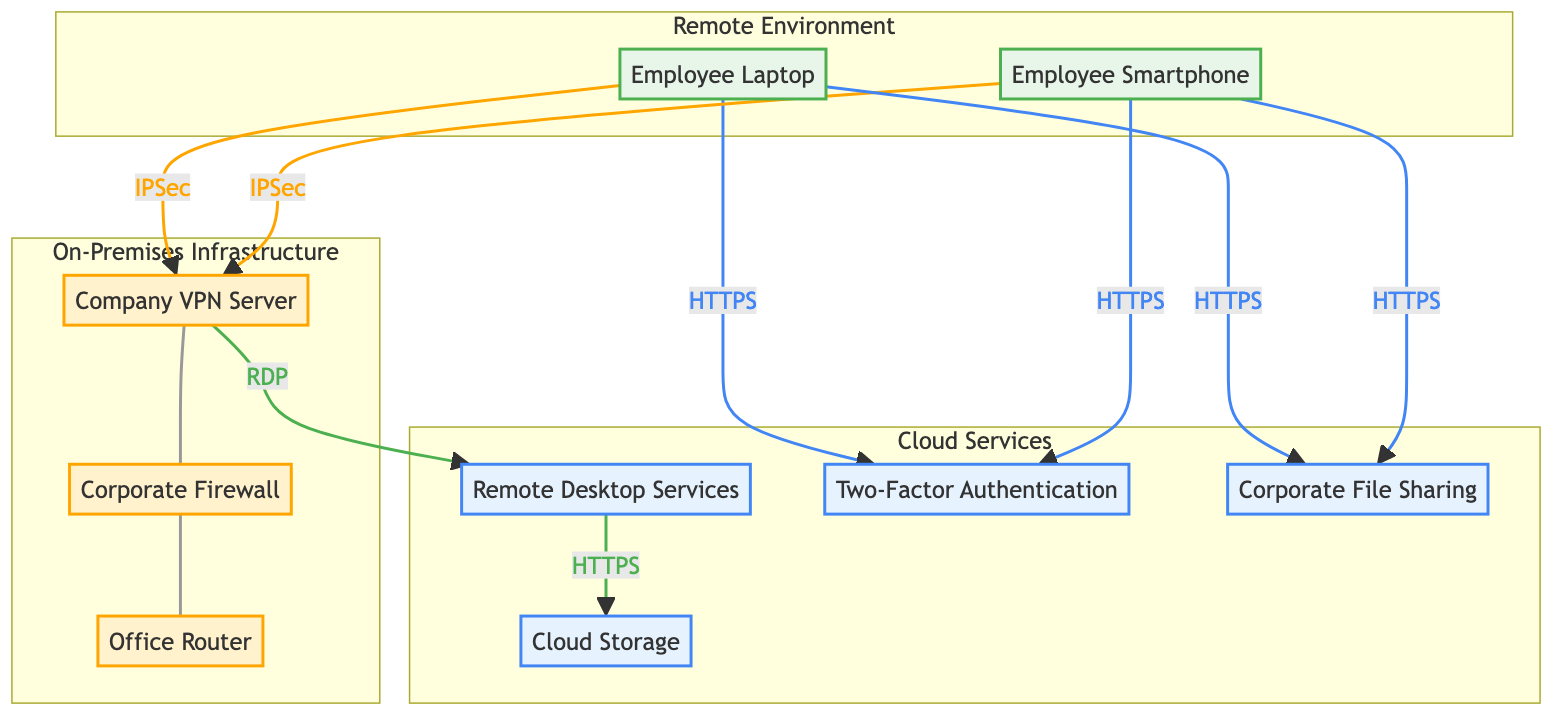What is the type of the "Company VPN Server"? The diagram indicates that the "Company VPN Server" is categorized as a "VPN Gateway".
Answer: VPN Gateway How many user endpoints are shown in the diagram? The diagram lists two user endpoints: an "Employee Laptop" and an "Employee Smartphone". Hence, the total count is 2.
Answer: 2 Which cloud service is used for cloud storage? According to the diagram, "Cloud Storage" is located in "AWS S3", indicating it is the cloud service implemented for storage purposes.
Answer: AWS S3 What protocol is used for the connection between "User Endpoints" and "Company VPN Server"? The diagram specifies that the connection is established via "IPSec" from "User Endpoints" to "Company VPN Server".
Answer: IPSec What kind of authentication is utilized in the system? The diagram mentions "Password" and "Two-Factor Authentication" as the authentication methods used, thus both are included.
Answer: Password, Two-Factor Authentication How does the "Remote Desktop Services" access "Cloud Storage"? The diagram clearly shows that "Remote Desktop Services" accesses "Cloud Storage" using the "HTTPS" protocol.
Answer: HTTPS What links the "Corporate Firewall" to the "Office Router"? According to the diagram, the "Corporate Firewall" is directly connected to the "Office Router". This indicates the relationship between the two components as shown in the visual flow.
Answer: Corporate Firewall, Office Router Which service is used for file sharing? The diagram identifies that "Corporate File Sharing" serves the purpose of file sharing as indicated in the services section.
Answer: Corporate File Sharing What type of service is "Two-Factor Authentication"? The diagram classifies "Two-Factor Authentication" as an "Authentication Service", defining its role within the network.
Answer: Authentication Service 